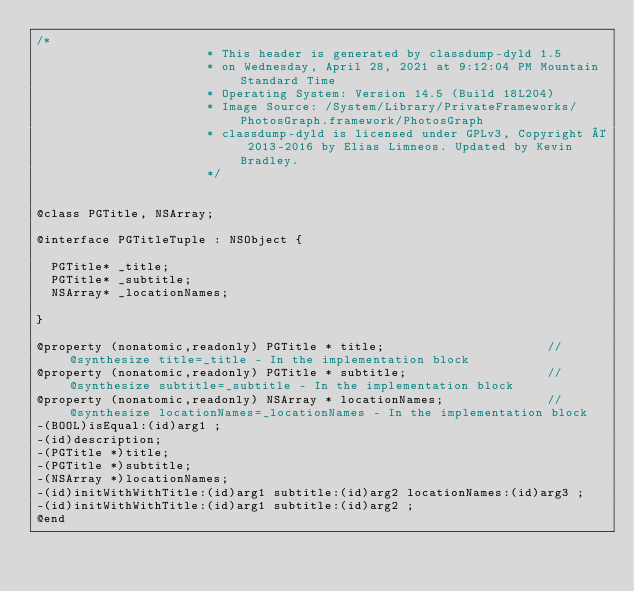Convert code to text. <code><loc_0><loc_0><loc_500><loc_500><_C_>/*
                       * This header is generated by classdump-dyld 1.5
                       * on Wednesday, April 28, 2021 at 9:12:04 PM Mountain Standard Time
                       * Operating System: Version 14.5 (Build 18L204)
                       * Image Source: /System/Library/PrivateFrameworks/PhotosGraph.framework/PhotosGraph
                       * classdump-dyld is licensed under GPLv3, Copyright © 2013-2016 by Elias Limneos. Updated by Kevin Bradley.
                       */


@class PGTitle, NSArray;

@interface PGTitleTuple : NSObject {

	PGTitle* _title;
	PGTitle* _subtitle;
	NSArray* _locationNames;

}

@property (nonatomic,readonly) PGTitle * title;                      //@synthesize title=_title - In the implementation block
@property (nonatomic,readonly) PGTitle * subtitle;                   //@synthesize subtitle=_subtitle - In the implementation block
@property (nonatomic,readonly) NSArray * locationNames;              //@synthesize locationNames=_locationNames - In the implementation block
-(BOOL)isEqual:(id)arg1 ;
-(id)description;
-(PGTitle *)title;
-(PGTitle *)subtitle;
-(NSArray *)locationNames;
-(id)initWithWithTitle:(id)arg1 subtitle:(id)arg2 locationNames:(id)arg3 ;
-(id)initWithWithTitle:(id)arg1 subtitle:(id)arg2 ;
@end

</code> 